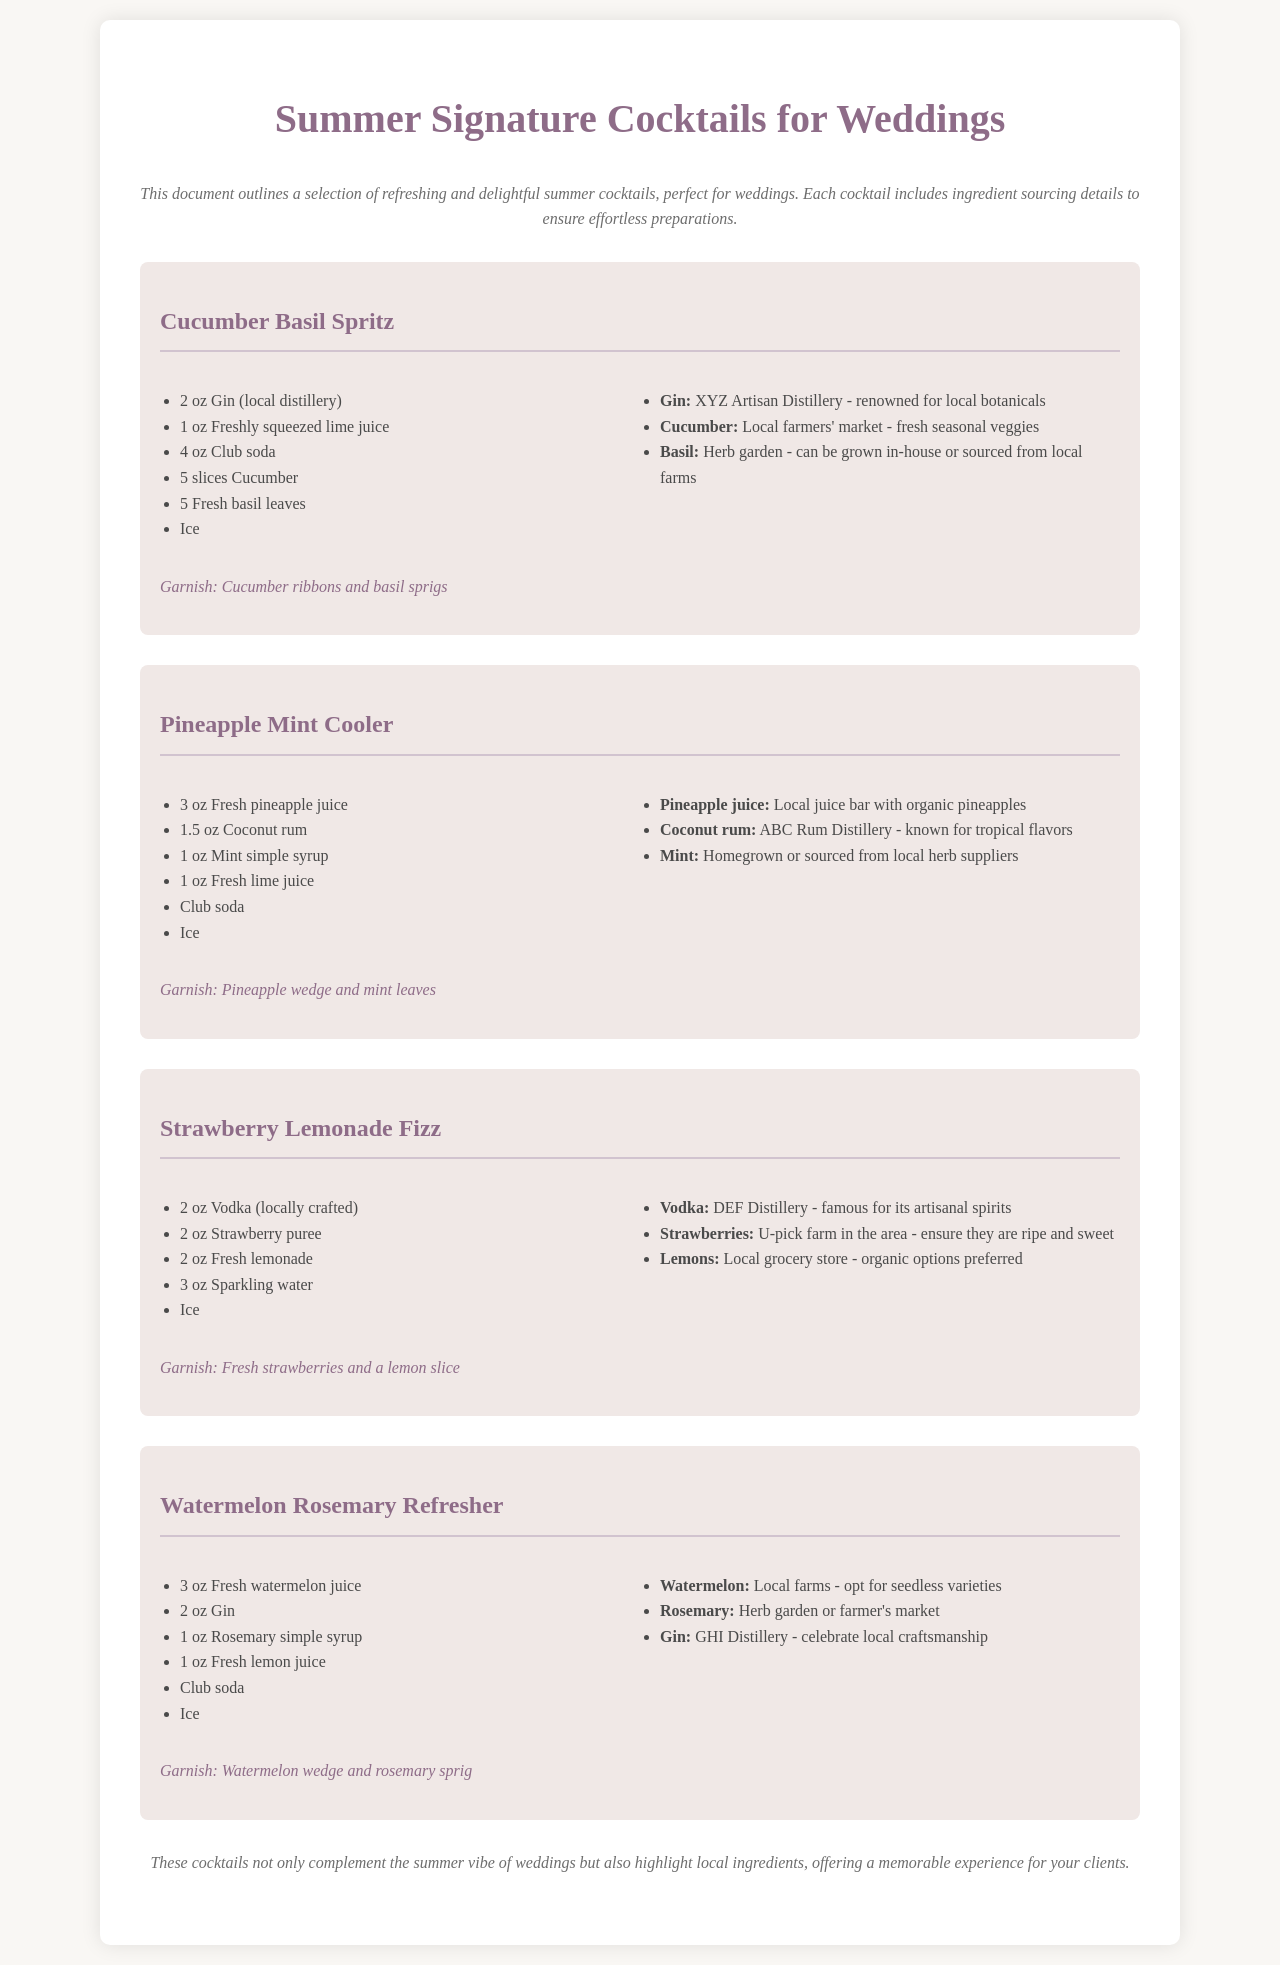What is the first cocktail listed? The first cocktail listed in the document is the "Cucumber Basil Spritz."
Answer: Cucumber Basil Spritz How many ounces of gin are in the Cucumber Basil Spritz? The recipe for Cucumber Basil Spritz includes 2 oz of gin.
Answer: 2 oz Where can the gin for the Cucumber Basil Spritz be sourced from? The gin can be sourced from a local distillery, specifically XYZ Artisan Distillery.
Answer: local distillery What are the garnishes for the Strawberry Lemonade Fizz? The garnishes for the Strawberry Lemonade Fizz are fresh strawberries and a lemon slice.
Answer: Fresh strawberries and a lemon slice Which cocktail contains pineapple juice? The cocktail that contains pineapple juice is the "Pineapple Mint Cooler."
Answer: Pineapple Mint Cooler How many cocktails are featured in the document? There are a total of four cocktails featured in the document.
Answer: four What herb is used in the Watermelon Rosemary Refresher? The herb used in the Watermelon Rosemary Refresher is rosemary.
Answer: rosemary What ingredient is sourced from a local grocery store for Strawberry Lemonade Fizz? Organic lemons are sourced from a local grocery store for the Strawberry Lemonade Fizz.
Answer: Organic lemons How does the document describe the summer cocktails? The document describes the summer cocktails as refreshing and delightful, perfect for weddings.
Answer: refreshing and delightful 